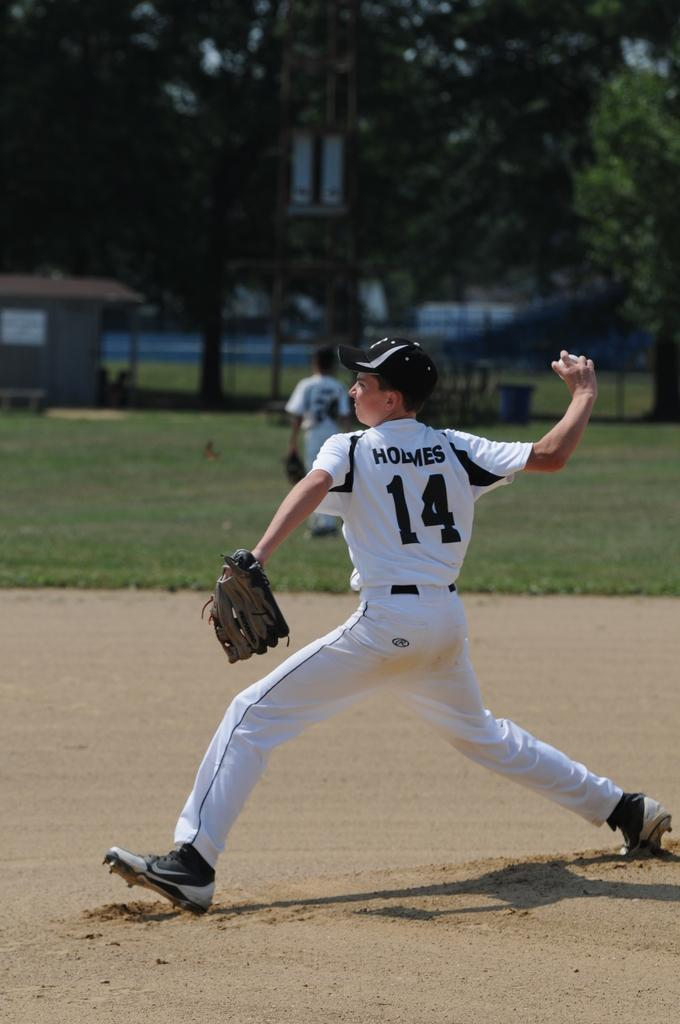Provide a one-sentence caption for the provided image. a baseball player with the name Holmes and #14 on the jersey in back. 